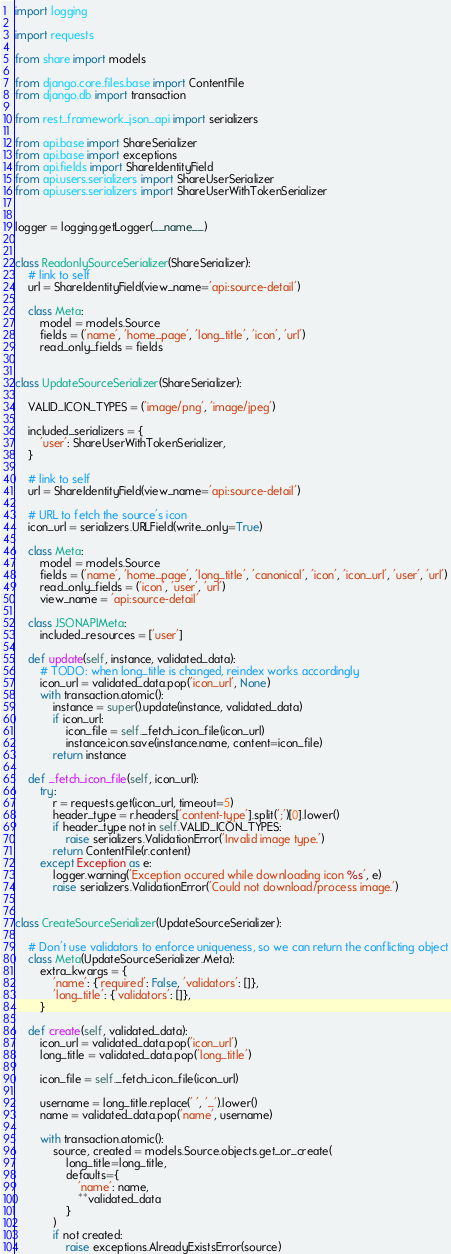<code> <loc_0><loc_0><loc_500><loc_500><_Python_>import logging

import requests

from share import models

from django.core.files.base import ContentFile
from django.db import transaction

from rest_framework_json_api import serializers

from api.base import ShareSerializer
from api.base import exceptions
from api.fields import ShareIdentityField
from api.users.serializers import ShareUserSerializer
from api.users.serializers import ShareUserWithTokenSerializer


logger = logging.getLogger(__name__)


class ReadonlySourceSerializer(ShareSerializer):
    # link to self
    url = ShareIdentityField(view_name='api:source-detail')

    class Meta:
        model = models.Source
        fields = ('name', 'home_page', 'long_title', 'icon', 'url')
        read_only_fields = fields


class UpdateSourceSerializer(ShareSerializer):

    VALID_ICON_TYPES = ('image/png', 'image/jpeg')

    included_serializers = {
        'user': ShareUserWithTokenSerializer,
    }

    # link to self
    url = ShareIdentityField(view_name='api:source-detail')

    # URL to fetch the source's icon
    icon_url = serializers.URLField(write_only=True)

    class Meta:
        model = models.Source
        fields = ('name', 'home_page', 'long_title', 'canonical', 'icon', 'icon_url', 'user', 'url')
        read_only_fields = ('icon', 'user', 'url')
        view_name = 'api:source-detail'

    class JSONAPIMeta:
        included_resources = ['user']

    def update(self, instance, validated_data):
        # TODO: when long_title is changed, reindex works accordingly
        icon_url = validated_data.pop('icon_url', None)
        with transaction.atomic():
            instance = super().update(instance, validated_data)
            if icon_url:
                icon_file = self._fetch_icon_file(icon_url)
                instance.icon.save(instance.name, content=icon_file)
            return instance

    def _fetch_icon_file(self, icon_url):
        try:
            r = requests.get(icon_url, timeout=5)
            header_type = r.headers['content-type'].split(';')[0].lower()
            if header_type not in self.VALID_ICON_TYPES:
                raise serializers.ValidationError('Invalid image type.')
            return ContentFile(r.content)
        except Exception as e:
            logger.warning('Exception occured while downloading icon %s', e)
            raise serializers.ValidationError('Could not download/process image.')


class CreateSourceSerializer(UpdateSourceSerializer):

    # Don't use validators to enforce uniqueness, so we can return the conflicting object
    class Meta(UpdateSourceSerializer.Meta):
        extra_kwargs = {
            'name': {'required': False, 'validators': []},
            'long_title': {'validators': []},
        }

    def create(self, validated_data):
        icon_url = validated_data.pop('icon_url')
        long_title = validated_data.pop('long_title')

        icon_file = self._fetch_icon_file(icon_url)

        username = long_title.replace(' ', '_').lower()
        name = validated_data.pop('name', username)

        with transaction.atomic():
            source, created = models.Source.objects.get_or_create(
                long_title=long_title,
                defaults={
                    'name': name,
                    **validated_data
                }
            )
            if not created:
                raise exceptions.AlreadyExistsError(source)
</code> 